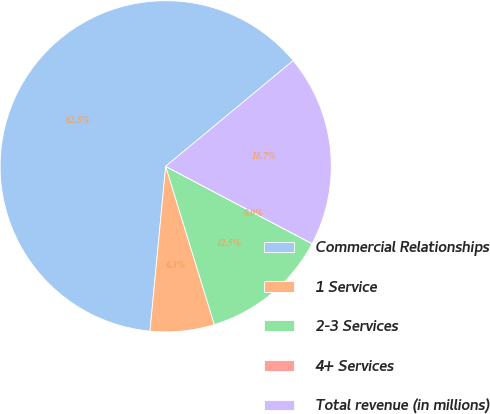Convert chart. <chart><loc_0><loc_0><loc_500><loc_500><pie_chart><fcel>Commercial Relationships<fcel>1 Service<fcel>2-3 Services<fcel>4+ Services<fcel>Total revenue (in millions)<nl><fcel>62.47%<fcel>6.26%<fcel>12.51%<fcel>0.01%<fcel>18.75%<nl></chart> 